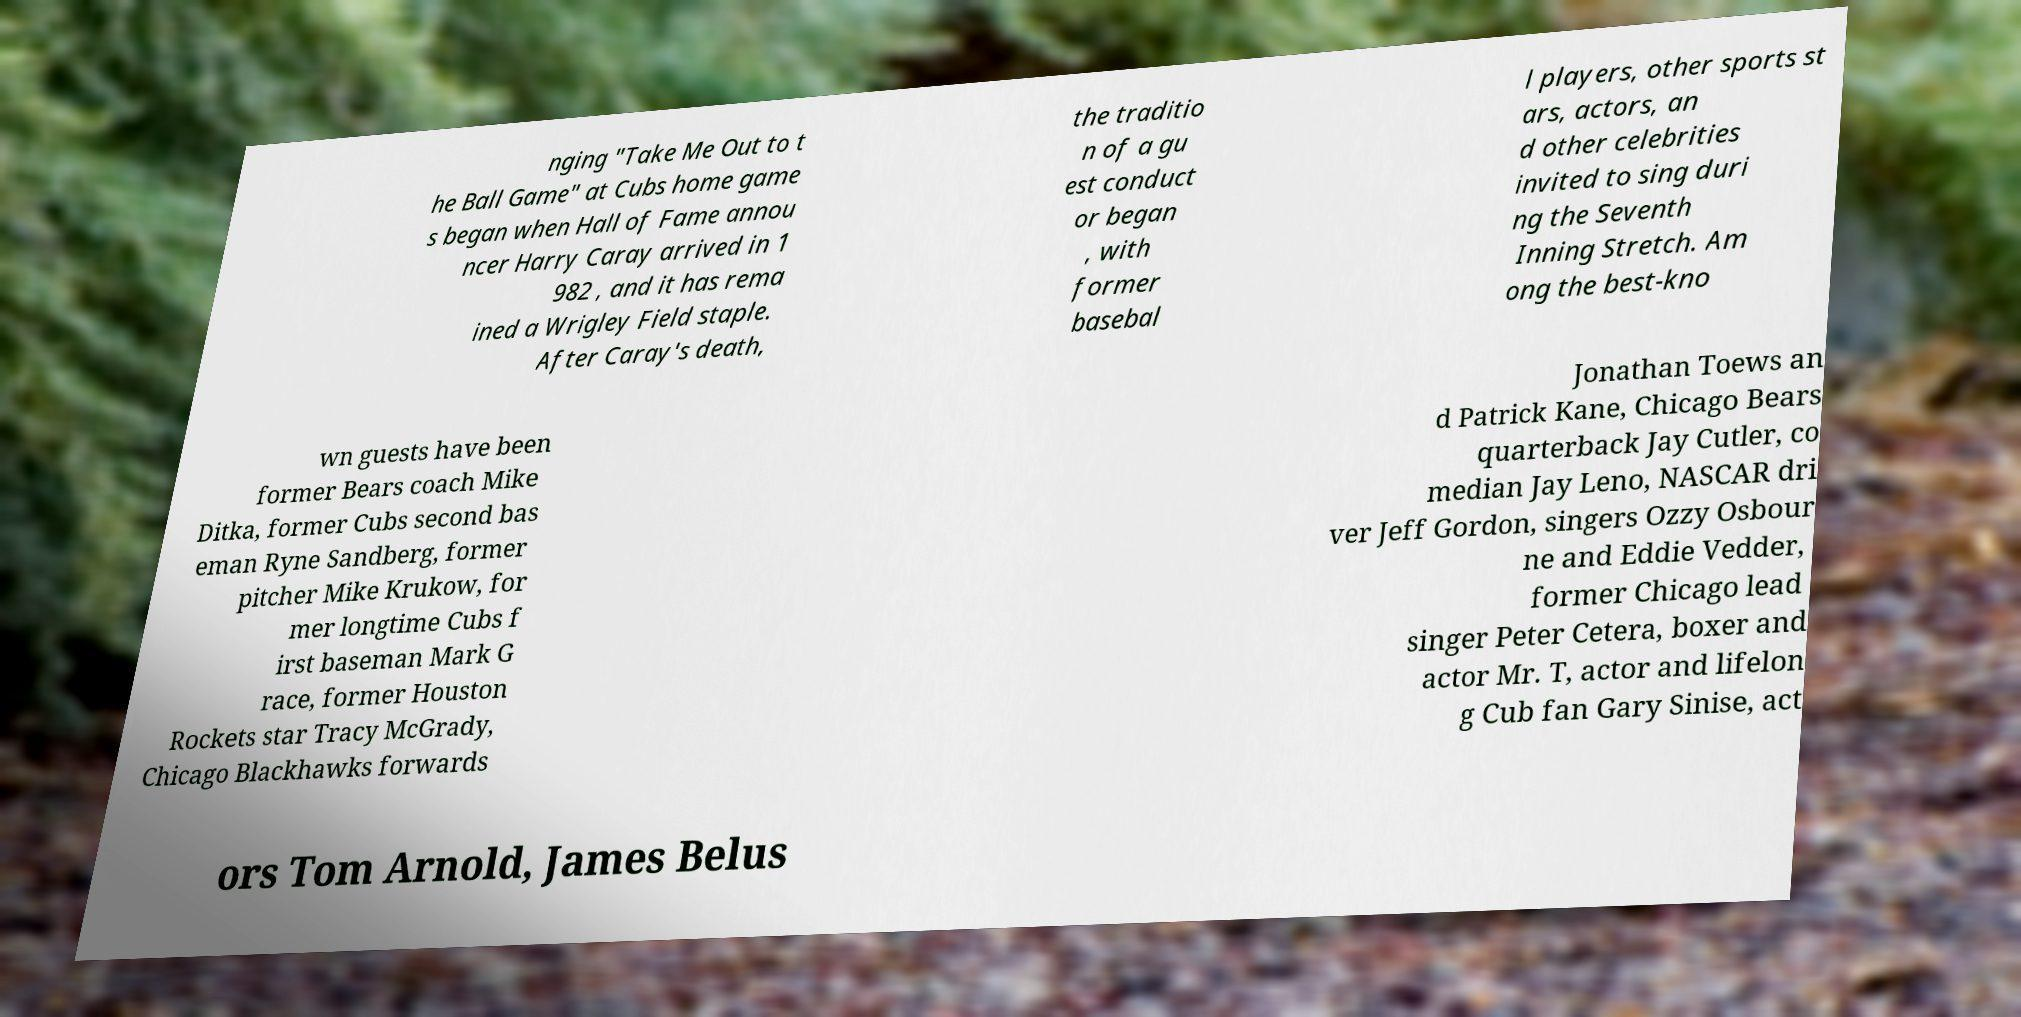Please read and relay the text visible in this image. What does it say? nging "Take Me Out to t he Ball Game" at Cubs home game s began when Hall of Fame annou ncer Harry Caray arrived in 1 982 , and it has rema ined a Wrigley Field staple. After Caray's death, the traditio n of a gu est conduct or began , with former basebal l players, other sports st ars, actors, an d other celebrities invited to sing duri ng the Seventh Inning Stretch. Am ong the best-kno wn guests have been former Bears coach Mike Ditka, former Cubs second bas eman Ryne Sandberg, former pitcher Mike Krukow, for mer longtime Cubs f irst baseman Mark G race, former Houston Rockets star Tracy McGrady, Chicago Blackhawks forwards Jonathan Toews an d Patrick Kane, Chicago Bears quarterback Jay Cutler, co median Jay Leno, NASCAR dri ver Jeff Gordon, singers Ozzy Osbour ne and Eddie Vedder, former Chicago lead singer Peter Cetera, boxer and actor Mr. T, actor and lifelon g Cub fan Gary Sinise, act ors Tom Arnold, James Belus 